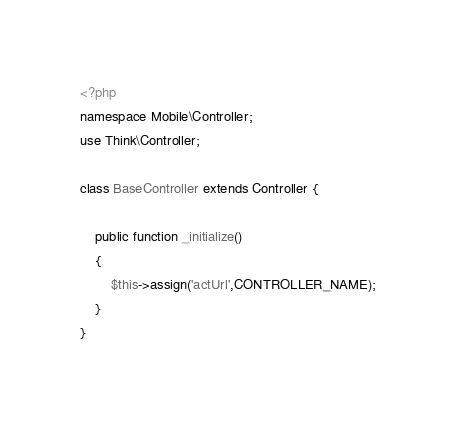Convert code to text. <code><loc_0><loc_0><loc_500><loc_500><_PHP_><?php
namespace Mobile\Controller;
use Think\Controller;

class BaseController extends Controller {

    public function _initialize()
    {
        $this->assign('actUrl',CONTROLLER_NAME);
    }
}</code> 